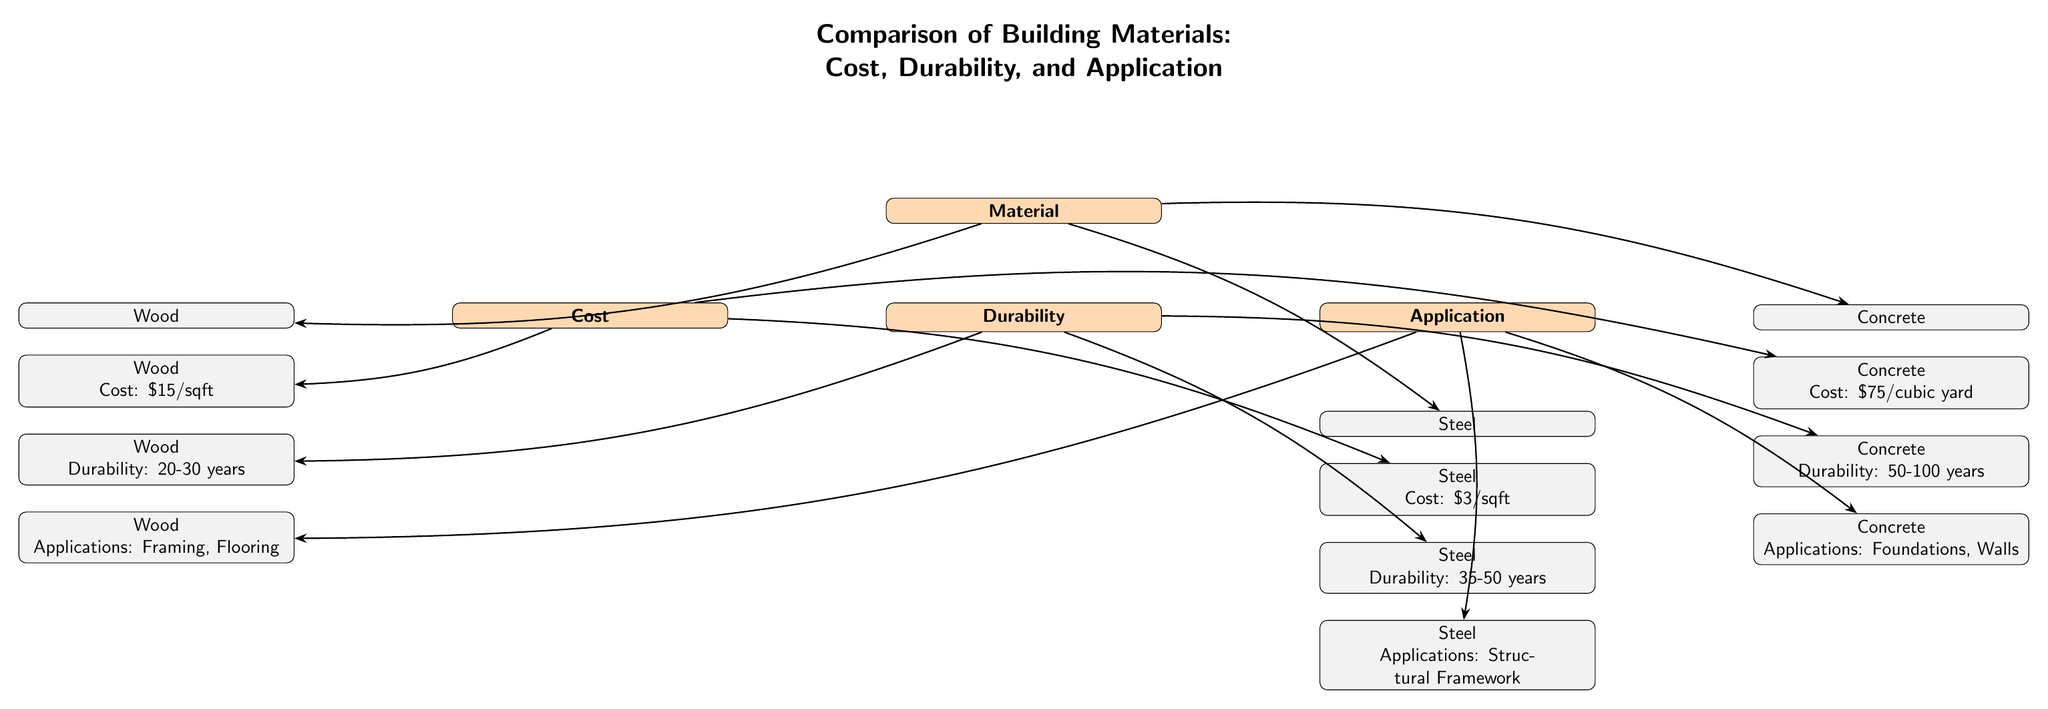What is the cost of wood per square foot? The diagram states the cost of wood is \$15 per square foot, which is found directly under the 'Cost' section linked to 'Wood'.
Answer: \$15/sqft What is the durability range of concrete? The durability of concrete is indicated in the 'Durability' section under 'Concrete' which specifies that it lasts 50-100 years.
Answer: 50-100 years Which material has the highest durability? By comparing the durability values from all three materials, concrete has the highest durability ranging from 50-100 years, while wood ranges from 20-30 years and steel from 35-50 years.
Answer: Concrete What applications are mentioned for steel? Under the 'Applications' section for steel, it mentions 'Structural Framework', which directly answers the question based on the information provided.
Answer: Structural Framework How many materials are compared in the diagram? The main 'Material' node leads to three different materials (Wood, Concrete, Steel), hence the count for materials is three.
Answer: Three What is the cost of steel per square foot? The diagram presents the cost of steel listed under the 'Cost' section, showing it as \$3 per square foot.
Answer: \$3/sqft Which material has the lowest cost? Comparing the costs, wood is \$15/sqft, concrete is \$75/cubic yard, and steel is \$3/sqft. Steel has the lowest cost, being \$3 per square foot.
Answer: Steel What is the durability of wood? The 'Durability' section under 'Wood' indicates that its durability ranges from 20 to 30 years, which is directly captured in the diagram.
Answer: 20-30 years What are the applications for concrete? The applications listed under the 'Concrete' heading specify 'Foundations, Walls', which answers the query about uses for this material.
Answer: Foundations, Walls 